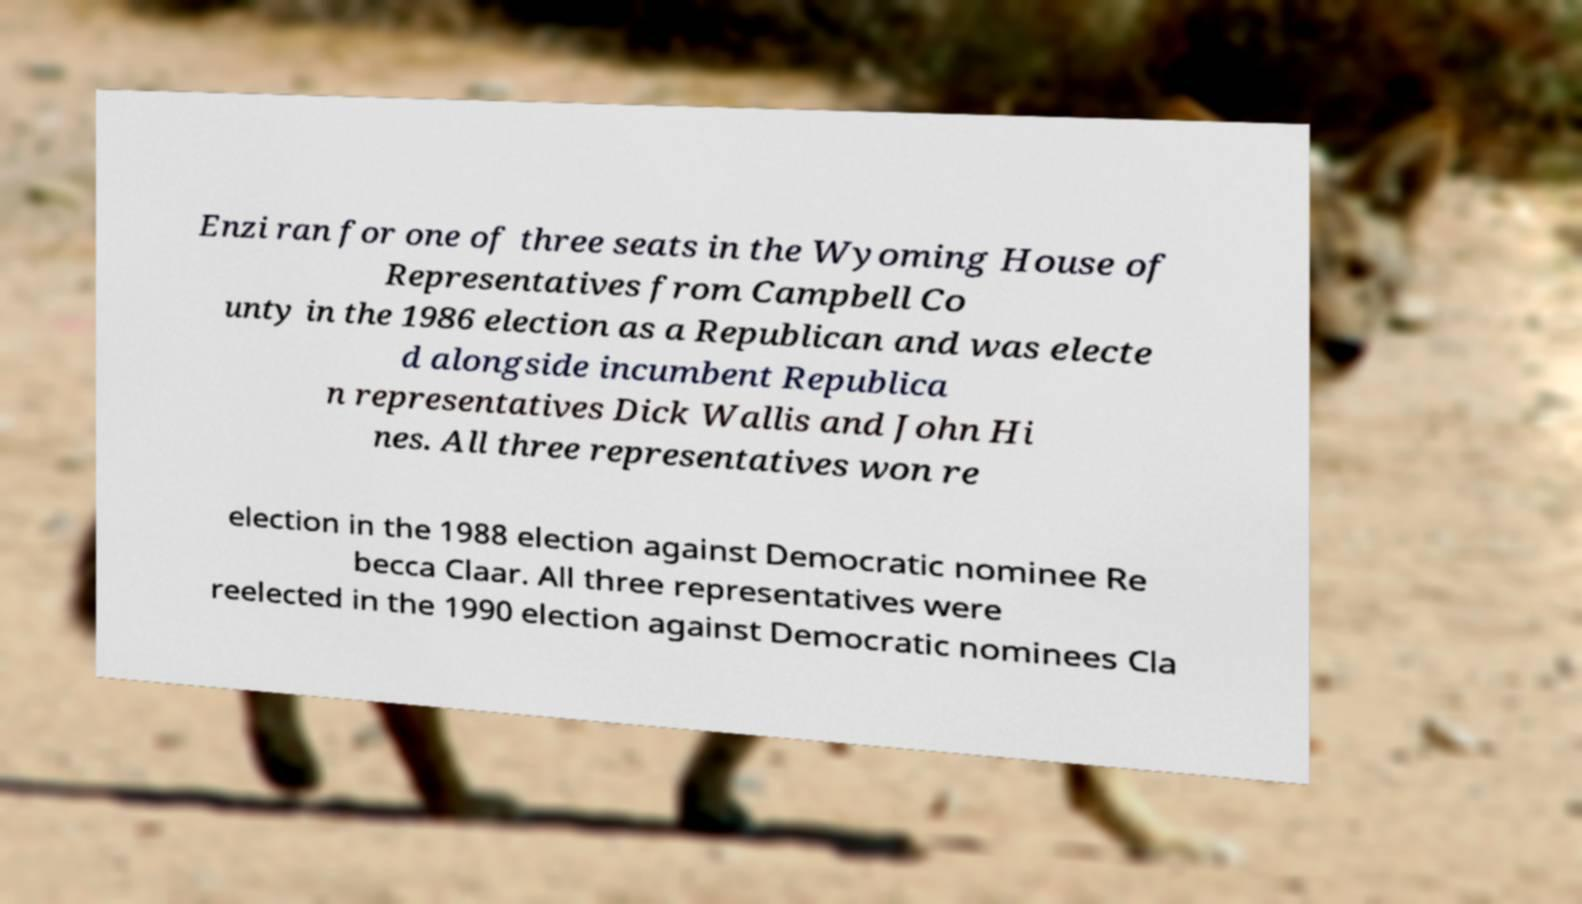Can you accurately transcribe the text from the provided image for me? Enzi ran for one of three seats in the Wyoming House of Representatives from Campbell Co unty in the 1986 election as a Republican and was electe d alongside incumbent Republica n representatives Dick Wallis and John Hi nes. All three representatives won re election in the 1988 election against Democratic nominee Re becca Claar. All three representatives were reelected in the 1990 election against Democratic nominees Cla 